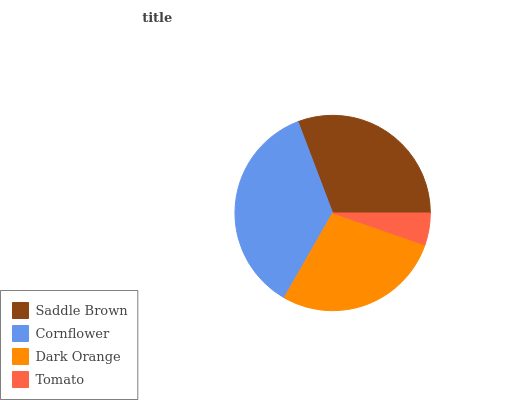Is Tomato the minimum?
Answer yes or no. Yes. Is Cornflower the maximum?
Answer yes or no. Yes. Is Dark Orange the minimum?
Answer yes or no. No. Is Dark Orange the maximum?
Answer yes or no. No. Is Cornflower greater than Dark Orange?
Answer yes or no. Yes. Is Dark Orange less than Cornflower?
Answer yes or no. Yes. Is Dark Orange greater than Cornflower?
Answer yes or no. No. Is Cornflower less than Dark Orange?
Answer yes or no. No. Is Saddle Brown the high median?
Answer yes or no. Yes. Is Dark Orange the low median?
Answer yes or no. Yes. Is Dark Orange the high median?
Answer yes or no. No. Is Saddle Brown the low median?
Answer yes or no. No. 